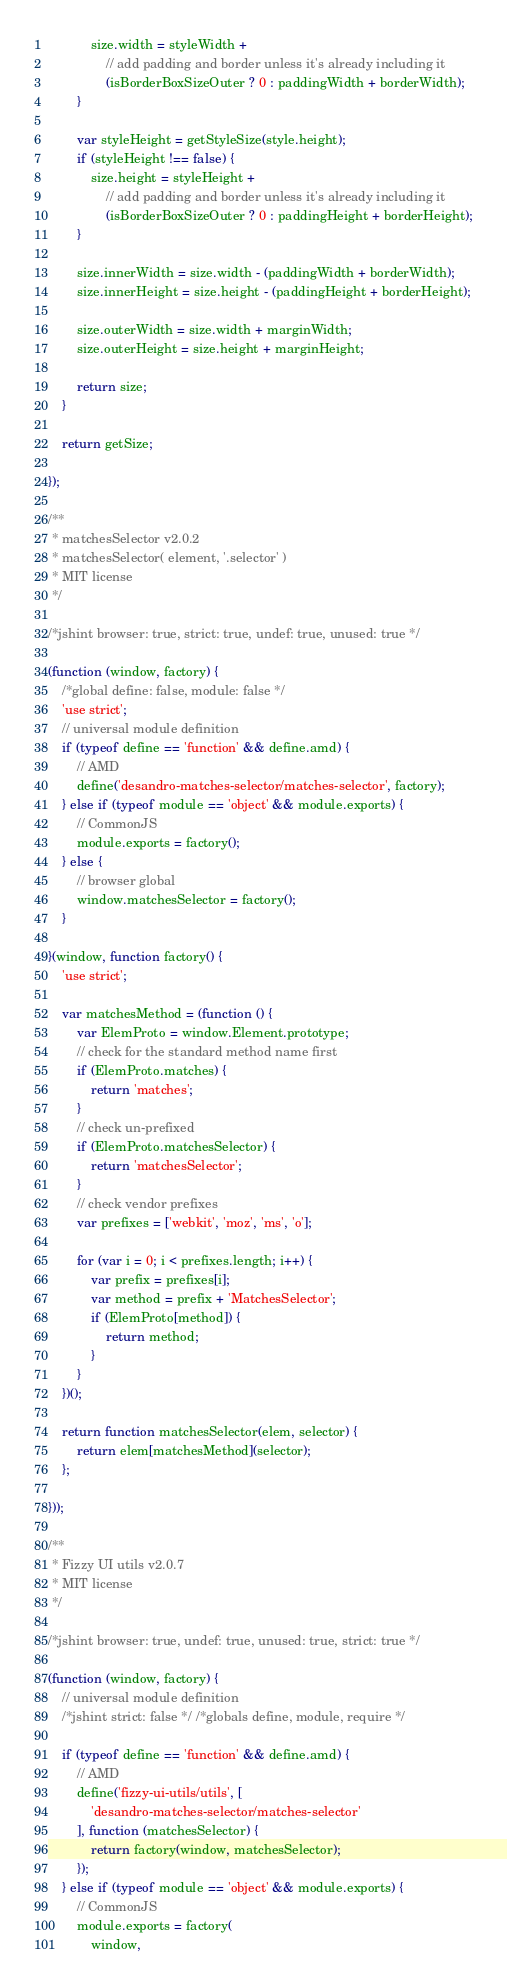<code> <loc_0><loc_0><loc_500><loc_500><_JavaScript_>            size.width = styleWidth +
                // add padding and border unless it's already including it
                (isBorderBoxSizeOuter ? 0 : paddingWidth + borderWidth);
        }

        var styleHeight = getStyleSize(style.height);
        if (styleHeight !== false) {
            size.height = styleHeight +
                // add padding and border unless it's already including it
                (isBorderBoxSizeOuter ? 0 : paddingHeight + borderHeight);
        }

        size.innerWidth = size.width - (paddingWidth + borderWidth);
        size.innerHeight = size.height - (paddingHeight + borderHeight);

        size.outerWidth = size.width + marginWidth;
        size.outerHeight = size.height + marginHeight;

        return size;
    }

    return getSize;

});

/**
 * matchesSelector v2.0.2
 * matchesSelector( element, '.selector' )
 * MIT license
 */

/*jshint browser: true, strict: true, undef: true, unused: true */

(function (window, factory) {
    /*global define: false, module: false */
    'use strict';
    // universal module definition
    if (typeof define == 'function' && define.amd) {
        // AMD
        define('desandro-matches-selector/matches-selector', factory);
    } else if (typeof module == 'object' && module.exports) {
        // CommonJS
        module.exports = factory();
    } else {
        // browser global
        window.matchesSelector = factory();
    }

}(window, function factory() {
    'use strict';

    var matchesMethod = (function () {
        var ElemProto = window.Element.prototype;
        // check for the standard method name first
        if (ElemProto.matches) {
            return 'matches';
        }
        // check un-prefixed
        if (ElemProto.matchesSelector) {
            return 'matchesSelector';
        }
        // check vendor prefixes
        var prefixes = ['webkit', 'moz', 'ms', 'o'];

        for (var i = 0; i < prefixes.length; i++) {
            var prefix = prefixes[i];
            var method = prefix + 'MatchesSelector';
            if (ElemProto[method]) {
                return method;
            }
        }
    })();

    return function matchesSelector(elem, selector) {
        return elem[matchesMethod](selector);
    };

}));

/**
 * Fizzy UI utils v2.0.7
 * MIT license
 */

/*jshint browser: true, undef: true, unused: true, strict: true */

(function (window, factory) {
    // universal module definition
    /*jshint strict: false */ /*globals define, module, require */

    if (typeof define == 'function' && define.amd) {
        // AMD
        define('fizzy-ui-utils/utils', [
            'desandro-matches-selector/matches-selector'
        ], function (matchesSelector) {
            return factory(window, matchesSelector);
        });
    } else if (typeof module == 'object' && module.exports) {
        // CommonJS
        module.exports = factory(
            window,</code> 